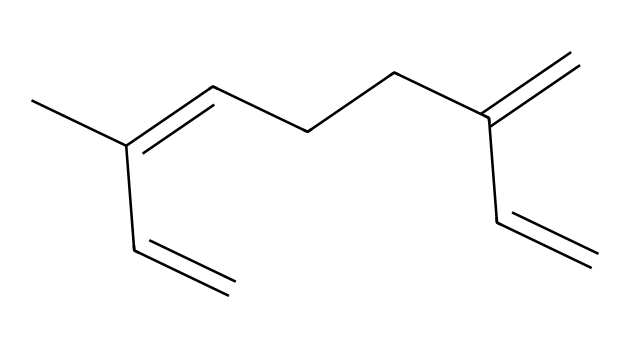How many carbon atoms are in myrcene? The chemical structure can be analyzed for the number of carbon atoms present. Each "C" in the SMILES indicates a carbon atom. In this structure, there are a total of 10 carbons counted.
Answer: 10 What is the primary functional group present in myrcene? The structure shows a series of double bonds, making it a hydrocarbon. The presence of multiple double bonds indicates that myrcene is an alkene, specifically a terpene.
Answer: alkene How many double bonds are there in myrcene? By examining the SMILES structure, the number of double bonds can be identified. Each "=" symbol represents a double bond. Here, there are a total of 3 double bonds present in the structure.
Answer: 3 What type of substance is myrcene classified as? The given chemical is a class of terpenoids based on its structural framework, which primarily consists of isoprene units. As a terpene, it is derived from plant sources, especially within cannabis.
Answer: terpene Which characteristic of myrcene is related to its aromatic properties? Myrcene, having a specific arrangement of double bonds and methyl groups, contributes to its aromatic properties, which are commonly associated with its scent and flavor profiles. The unsaturation gives rise to its distinct aroma.
Answer: aroma What is myrcene's relevance in marijuana policy discussions? Myrcene's properties heavily influence the effects of cannabis, including potential therapeutic benefits, which is central to discussions around its legalization and medicinal use, especially relating to pain relief and sedative effects.
Answer: therapeutic benefits 